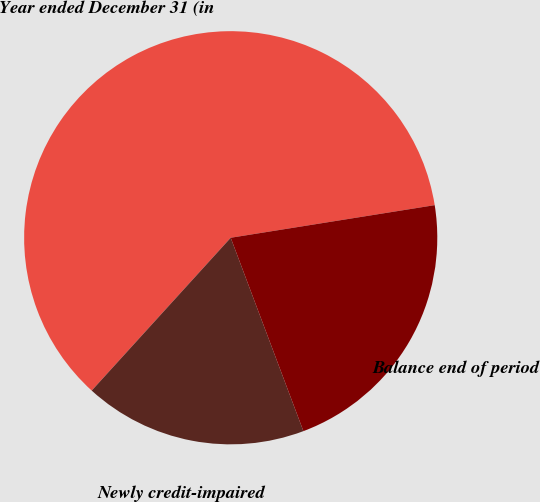Convert chart to OTSL. <chart><loc_0><loc_0><loc_500><loc_500><pie_chart><fcel>Year ended December 31 (in<fcel>Newly credit-impaired<fcel>Balance end of period<nl><fcel>60.73%<fcel>17.47%<fcel>21.8%<nl></chart> 